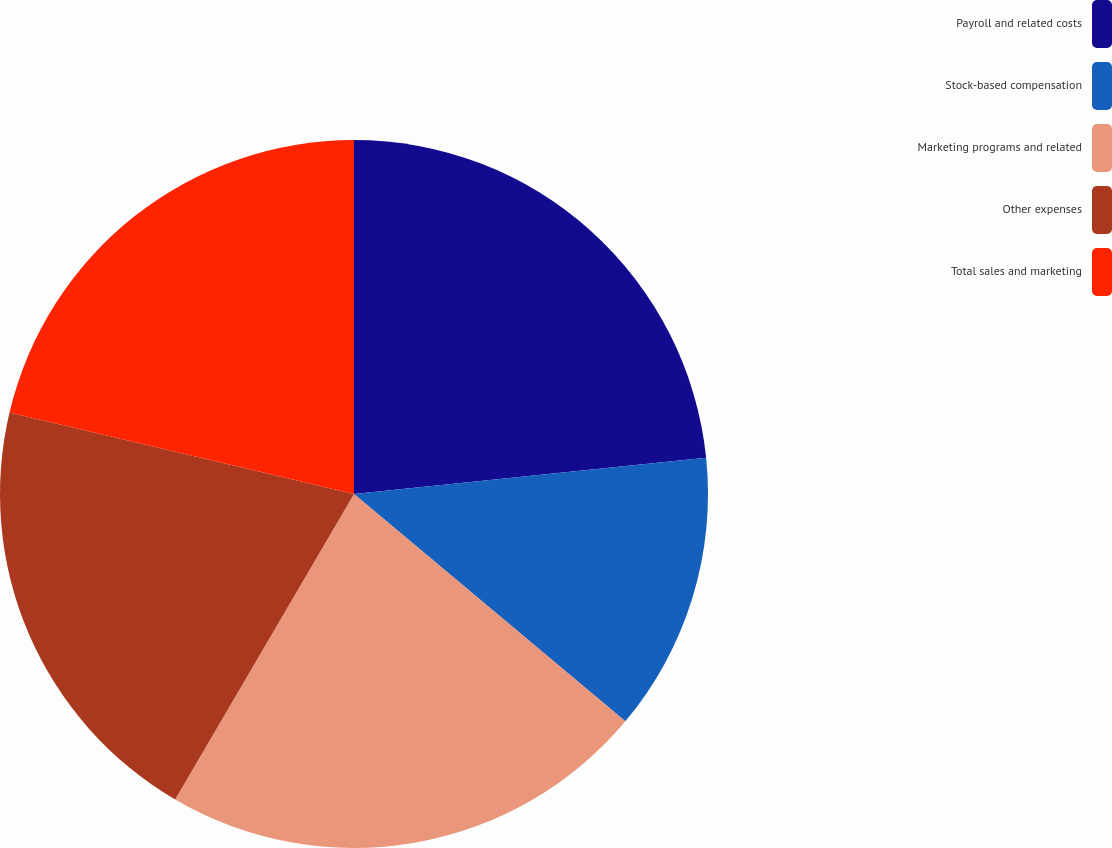<chart> <loc_0><loc_0><loc_500><loc_500><pie_chart><fcel>Payroll and related costs<fcel>Stock-based compensation<fcel>Marketing programs and related<fcel>Other expenses<fcel>Total sales and marketing<nl><fcel>23.37%<fcel>12.73%<fcel>22.33%<fcel>20.27%<fcel>21.3%<nl></chart> 